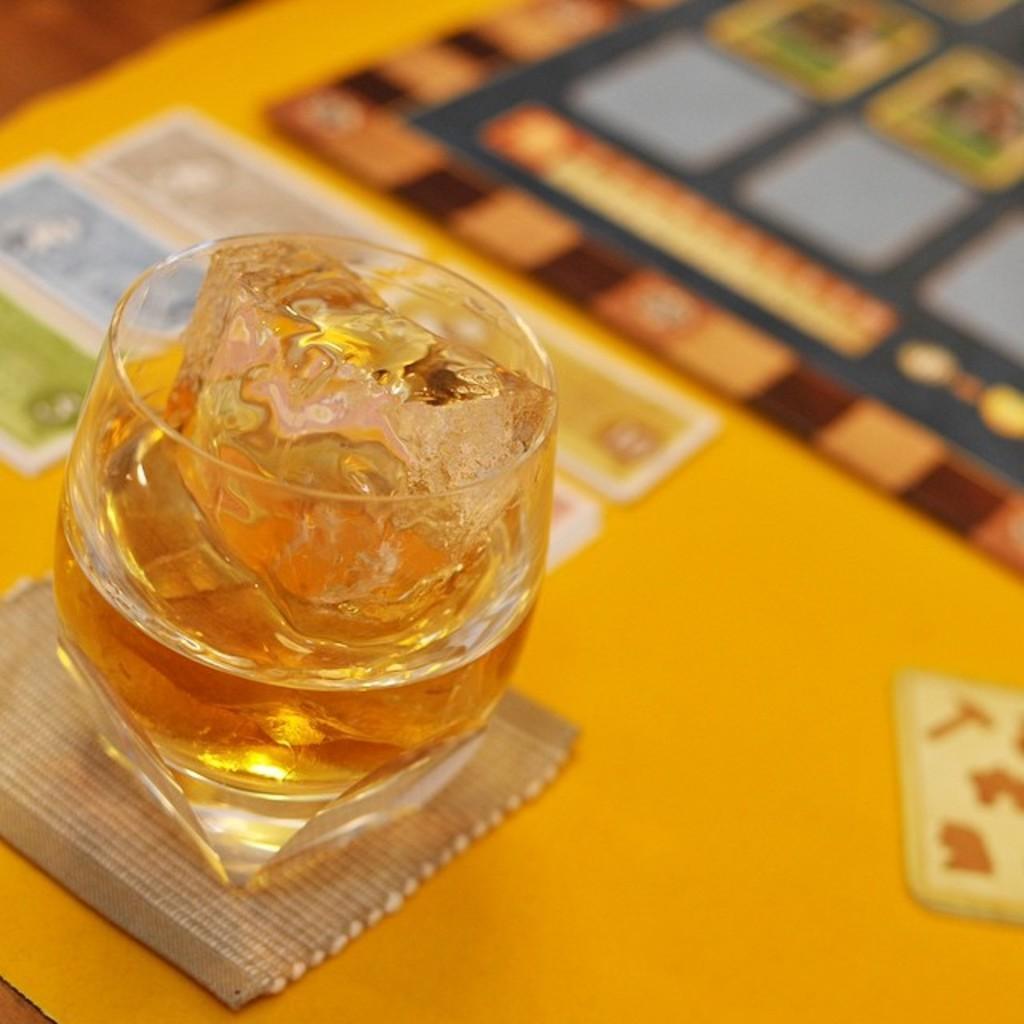Please provide a concise description of this image. In this image there are cards and drink on the table. 